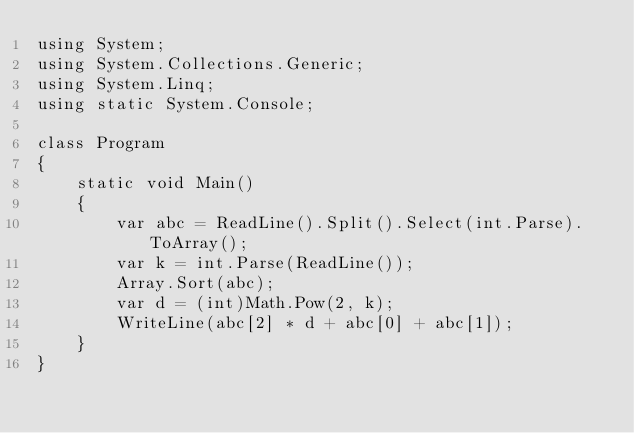Convert code to text. <code><loc_0><loc_0><loc_500><loc_500><_C#_>using System;
using System.Collections.Generic;
using System.Linq;
using static System.Console;

class Program
{
    static void Main()
    {
        var abc = ReadLine().Split().Select(int.Parse).ToArray();
        var k = int.Parse(ReadLine());
        Array.Sort(abc);
        var d = (int)Math.Pow(2, k);
        WriteLine(abc[2] * d + abc[0] + abc[1]);
    }
}
</code> 